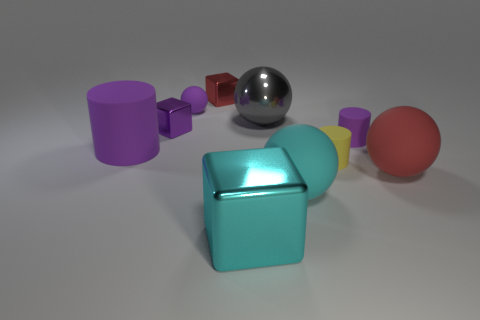Subtract all cyan shiny cubes. How many cubes are left? 2 Subtract all purple spheres. How many spheres are left? 3 Subtract all cylinders. How many objects are left? 7 Subtract 3 balls. How many balls are left? 1 Subtract all yellow balls. Subtract all purple cylinders. How many balls are left? 4 Subtract all green balls. How many cyan cubes are left? 1 Subtract all large shiny spheres. Subtract all tiny purple matte objects. How many objects are left? 7 Add 7 large purple rubber cylinders. How many large purple rubber cylinders are left? 8 Add 8 tiny gray rubber balls. How many tiny gray rubber balls exist? 8 Subtract 0 blue cubes. How many objects are left? 10 